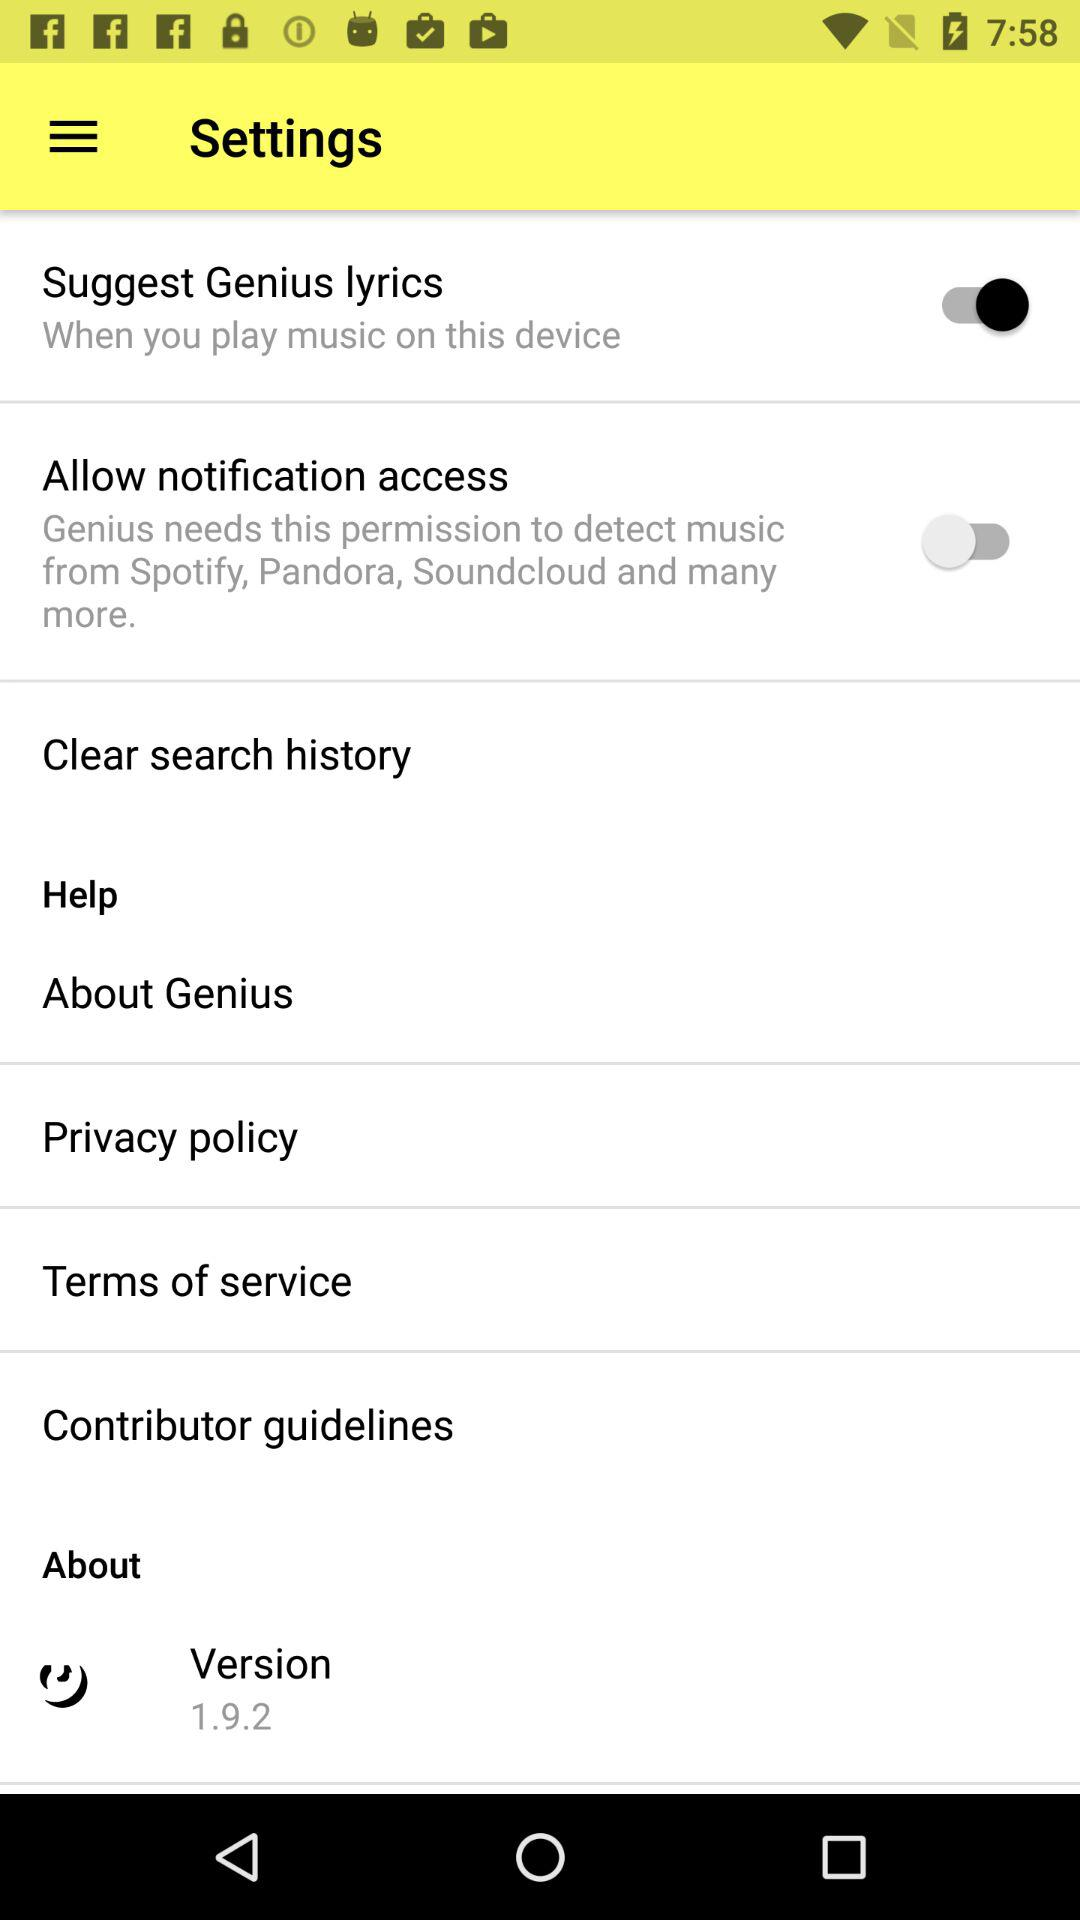How many items have a switch?
Answer the question using a single word or phrase. 2 